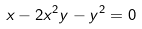<formula> <loc_0><loc_0><loc_500><loc_500>x - 2 x ^ { 2 } y - y ^ { 2 } = 0</formula> 